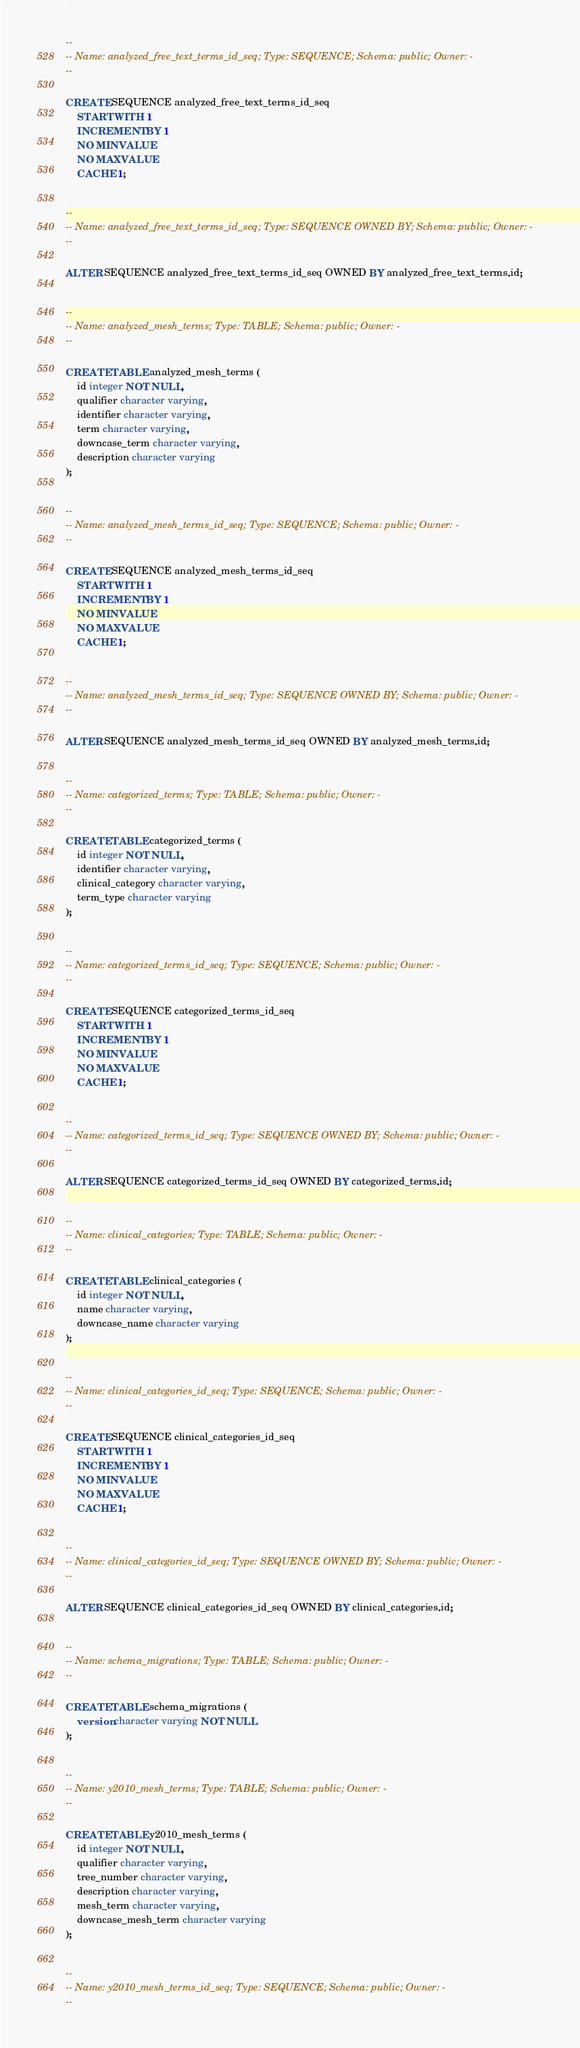<code> <loc_0><loc_0><loc_500><loc_500><_SQL_>
--
-- Name: analyzed_free_text_terms_id_seq; Type: SEQUENCE; Schema: public; Owner: -
--

CREATE SEQUENCE analyzed_free_text_terms_id_seq
    START WITH 1
    INCREMENT BY 1
    NO MINVALUE
    NO MAXVALUE
    CACHE 1;


--
-- Name: analyzed_free_text_terms_id_seq; Type: SEQUENCE OWNED BY; Schema: public; Owner: -
--

ALTER SEQUENCE analyzed_free_text_terms_id_seq OWNED BY analyzed_free_text_terms.id;


--
-- Name: analyzed_mesh_terms; Type: TABLE; Schema: public; Owner: -
--

CREATE TABLE analyzed_mesh_terms (
    id integer NOT NULL,
    qualifier character varying,
    identifier character varying,
    term character varying,
    downcase_term character varying,
    description character varying
);


--
-- Name: analyzed_mesh_terms_id_seq; Type: SEQUENCE; Schema: public; Owner: -
--

CREATE SEQUENCE analyzed_mesh_terms_id_seq
    START WITH 1
    INCREMENT BY 1
    NO MINVALUE
    NO MAXVALUE
    CACHE 1;


--
-- Name: analyzed_mesh_terms_id_seq; Type: SEQUENCE OWNED BY; Schema: public; Owner: -
--

ALTER SEQUENCE analyzed_mesh_terms_id_seq OWNED BY analyzed_mesh_terms.id;


--
-- Name: categorized_terms; Type: TABLE; Schema: public; Owner: -
--

CREATE TABLE categorized_terms (
    id integer NOT NULL,
    identifier character varying,
    clinical_category character varying,
    term_type character varying
);


--
-- Name: categorized_terms_id_seq; Type: SEQUENCE; Schema: public; Owner: -
--

CREATE SEQUENCE categorized_terms_id_seq
    START WITH 1
    INCREMENT BY 1
    NO MINVALUE
    NO MAXVALUE
    CACHE 1;


--
-- Name: categorized_terms_id_seq; Type: SEQUENCE OWNED BY; Schema: public; Owner: -
--

ALTER SEQUENCE categorized_terms_id_seq OWNED BY categorized_terms.id;


--
-- Name: clinical_categories; Type: TABLE; Schema: public; Owner: -
--

CREATE TABLE clinical_categories (
    id integer NOT NULL,
    name character varying,
    downcase_name character varying
);


--
-- Name: clinical_categories_id_seq; Type: SEQUENCE; Schema: public; Owner: -
--

CREATE SEQUENCE clinical_categories_id_seq
    START WITH 1
    INCREMENT BY 1
    NO MINVALUE
    NO MAXVALUE
    CACHE 1;


--
-- Name: clinical_categories_id_seq; Type: SEQUENCE OWNED BY; Schema: public; Owner: -
--

ALTER SEQUENCE clinical_categories_id_seq OWNED BY clinical_categories.id;


--
-- Name: schema_migrations; Type: TABLE; Schema: public; Owner: -
--

CREATE TABLE schema_migrations (
    version character varying NOT NULL
);


--
-- Name: y2010_mesh_terms; Type: TABLE; Schema: public; Owner: -
--

CREATE TABLE y2010_mesh_terms (
    id integer NOT NULL,
    qualifier character varying,
    tree_number character varying,
    description character varying,
    mesh_term character varying,
    downcase_mesh_term character varying
);


--
-- Name: y2010_mesh_terms_id_seq; Type: SEQUENCE; Schema: public; Owner: -
--
</code> 